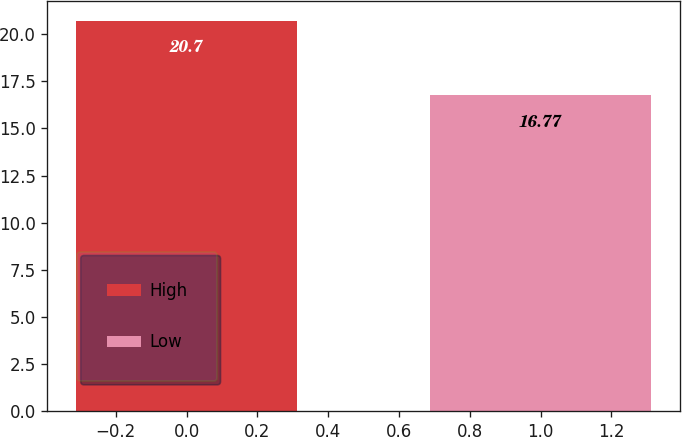<chart> <loc_0><loc_0><loc_500><loc_500><bar_chart><fcel>High<fcel>Low<nl><fcel>20.7<fcel>16.77<nl></chart> 